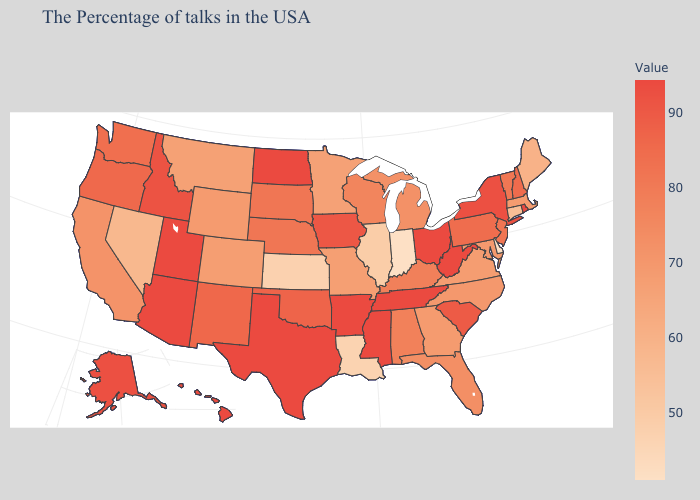Does Georgia have the lowest value in the USA?
Answer briefly. No. Does Hawaii have the lowest value in the USA?
Short answer required. No. Does Indiana have the lowest value in the USA?
Answer briefly. Yes. Does Rhode Island have the lowest value in the Northeast?
Write a very short answer. No. 